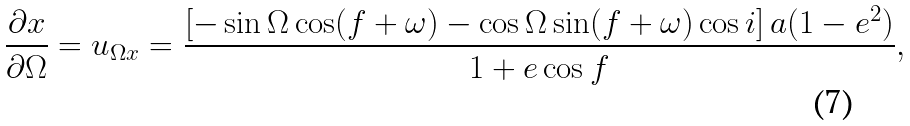Convert formula to latex. <formula><loc_0><loc_0><loc_500><loc_500>\frac { \partial x } { \partial \Omega } = u _ { \Omega x } = \frac { \left [ - \sin \Omega \cos ( f + \omega ) - \cos \Omega \sin ( f + \omega ) \cos i \right ] a ( 1 - e ^ { 2 } ) } { 1 + e \cos f } ,</formula> 